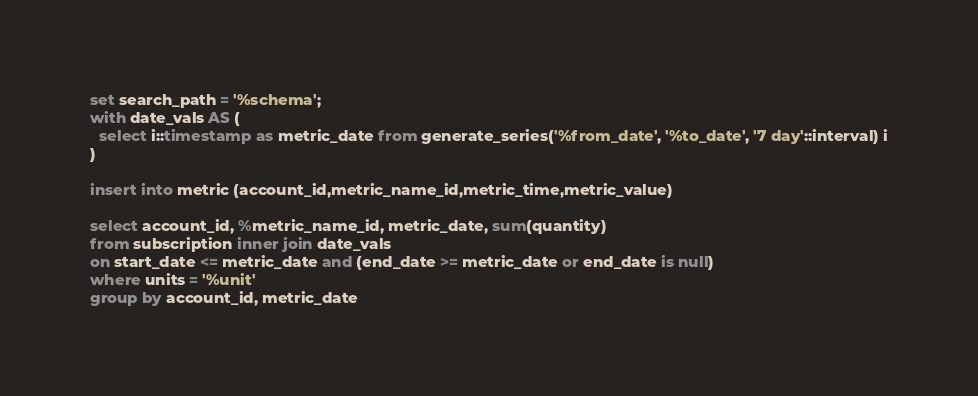Convert code to text. <code><loc_0><loc_0><loc_500><loc_500><_SQL_>set search_path = '%schema';
with date_vals AS (
  select i::timestamp as metric_date from generate_series('%from_date', '%to_date', '7 day'::interval) i
)

insert into metric (account_id,metric_name_id,metric_time,metric_value)

select account_id, %metric_name_id, metric_date, sum(quantity)
from subscription inner join date_vals
on start_date <= metric_date and (end_date >= metric_date or end_date is null)
where units = '%unit'
group by account_id, metric_date

</code> 